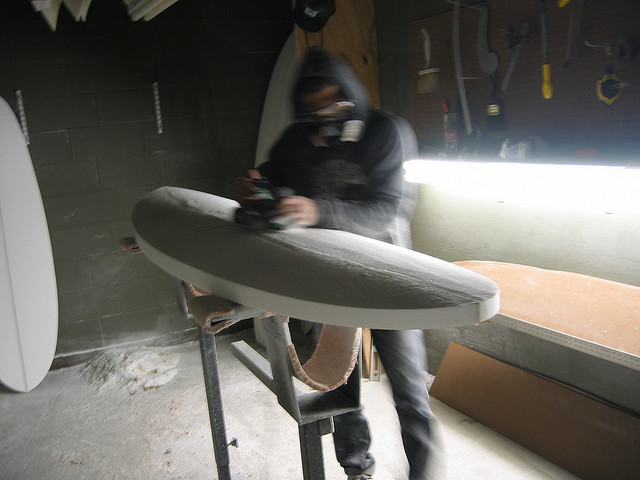What is the man wearing on his head? The man in the image is wearing a hood on his head which is part of his sweatshirt. It's designed to protect his head and hair from the dust and particles created from the surfboard shaping process he is involved in. 